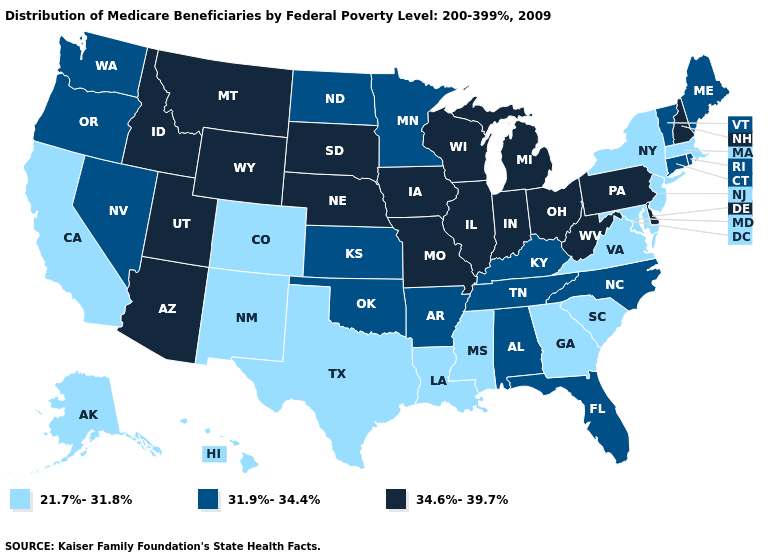Does Wyoming have a lower value than Oklahoma?
Concise answer only. No. Name the states that have a value in the range 34.6%-39.7%?
Be succinct. Arizona, Delaware, Idaho, Illinois, Indiana, Iowa, Michigan, Missouri, Montana, Nebraska, New Hampshire, Ohio, Pennsylvania, South Dakota, Utah, West Virginia, Wisconsin, Wyoming. Does Minnesota have the lowest value in the MidWest?
Be succinct. Yes. Among the states that border Utah , does Arizona have the highest value?
Write a very short answer. Yes. Which states have the lowest value in the West?
Answer briefly. Alaska, California, Colorado, Hawaii, New Mexico. Name the states that have a value in the range 21.7%-31.8%?
Answer briefly. Alaska, California, Colorado, Georgia, Hawaii, Louisiana, Maryland, Massachusetts, Mississippi, New Jersey, New Mexico, New York, South Carolina, Texas, Virginia. Which states have the lowest value in the USA?
Write a very short answer. Alaska, California, Colorado, Georgia, Hawaii, Louisiana, Maryland, Massachusetts, Mississippi, New Jersey, New Mexico, New York, South Carolina, Texas, Virginia. Among the states that border New York , which have the lowest value?
Be succinct. Massachusetts, New Jersey. Among the states that border Vermont , which have the lowest value?
Short answer required. Massachusetts, New York. Does Minnesota have the highest value in the USA?
Short answer required. No. Name the states that have a value in the range 31.9%-34.4%?
Short answer required. Alabama, Arkansas, Connecticut, Florida, Kansas, Kentucky, Maine, Minnesota, Nevada, North Carolina, North Dakota, Oklahoma, Oregon, Rhode Island, Tennessee, Vermont, Washington. What is the value of West Virginia?
Short answer required. 34.6%-39.7%. Which states have the highest value in the USA?
Quick response, please. Arizona, Delaware, Idaho, Illinois, Indiana, Iowa, Michigan, Missouri, Montana, Nebraska, New Hampshire, Ohio, Pennsylvania, South Dakota, Utah, West Virginia, Wisconsin, Wyoming. What is the highest value in the South ?
Write a very short answer. 34.6%-39.7%. Name the states that have a value in the range 34.6%-39.7%?
Give a very brief answer. Arizona, Delaware, Idaho, Illinois, Indiana, Iowa, Michigan, Missouri, Montana, Nebraska, New Hampshire, Ohio, Pennsylvania, South Dakota, Utah, West Virginia, Wisconsin, Wyoming. 